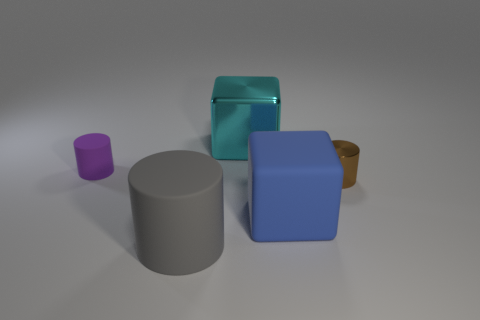Is the size of the gray cylinder the same as the object that is behind the tiny purple rubber cylinder?
Ensure brevity in your answer.  Yes. The cylinder in front of the small cylinder that is to the right of the blue thing is what color?
Make the answer very short. Gray. Is the size of the blue object the same as the brown cylinder?
Ensure brevity in your answer.  No. There is a object that is on the right side of the large blue matte thing; what number of large blue blocks are to the right of it?
Provide a succinct answer. 0. Does the blue matte object have the same shape as the tiny brown metallic object?
Offer a very short reply. No. What size is the purple rubber thing that is the same shape as the tiny brown thing?
Keep it short and to the point. Small. The big thing that is on the left side of the thing that is behind the purple cylinder is what shape?
Give a very brief answer. Cylinder. Is the shape of the blue rubber object the same as the big thing that is behind the tiny brown cylinder?
Give a very brief answer. Yes. Do the large rubber object that is in front of the big blue object and the cyan thing have the same shape?
Your answer should be compact. No. How many matte objects are both behind the big gray rubber thing and in front of the rubber block?
Make the answer very short. 0. 